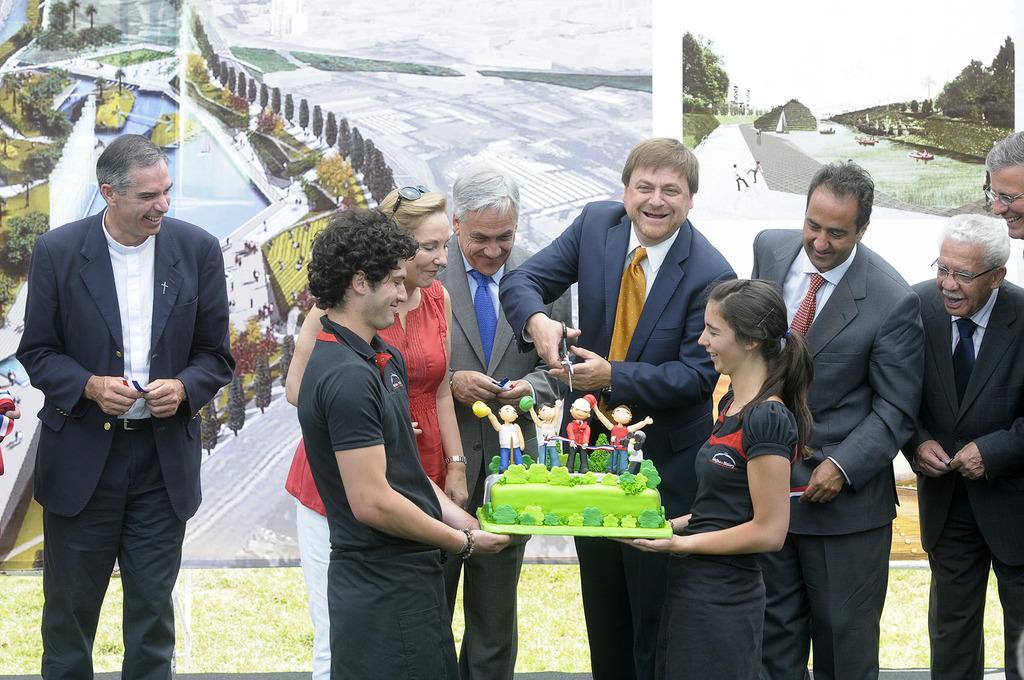Can you describe this image briefly? In this picture there are group of people standing and smiling and there is a man standing and holding the scissors. There are two people standing and smiling and might be holding the cake. At the back there is a board. On the board there is a picture of a city and mountain. At the bottom there is grass. 